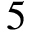<formula> <loc_0><loc_0><loc_500><loc_500>5</formula> 